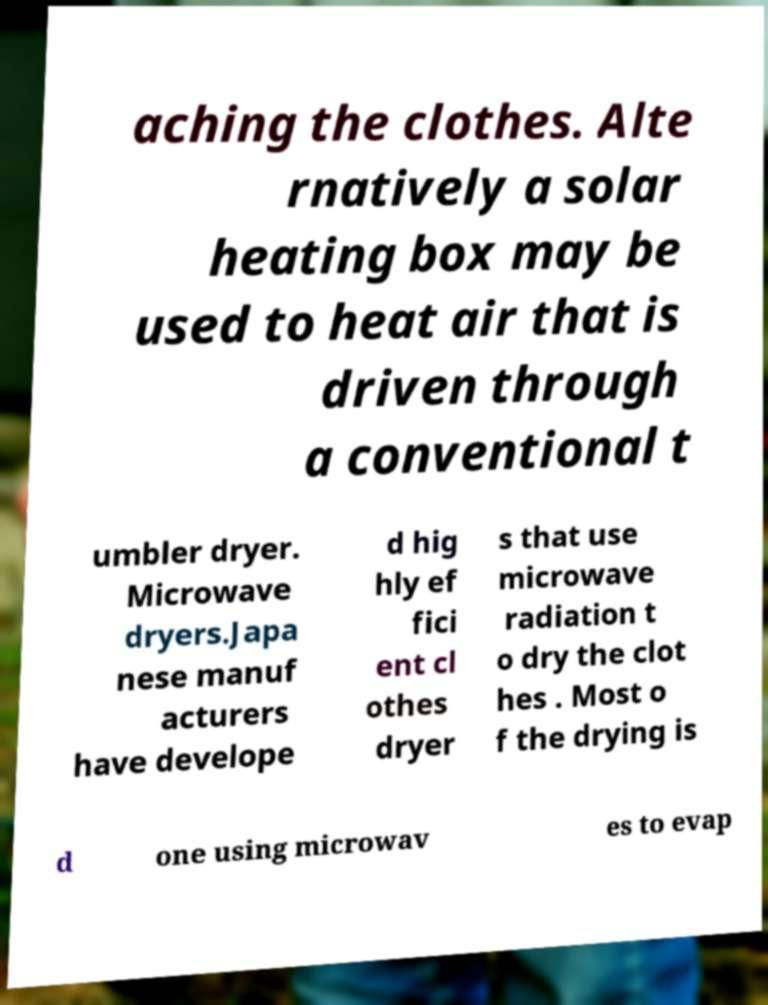I need the written content from this picture converted into text. Can you do that? aching the clothes. Alte rnatively a solar heating box may be used to heat air that is driven through a conventional t umbler dryer. Microwave dryers.Japa nese manuf acturers have develope d hig hly ef fici ent cl othes dryer s that use microwave radiation t o dry the clot hes . Most o f the drying is d one using microwav es to evap 